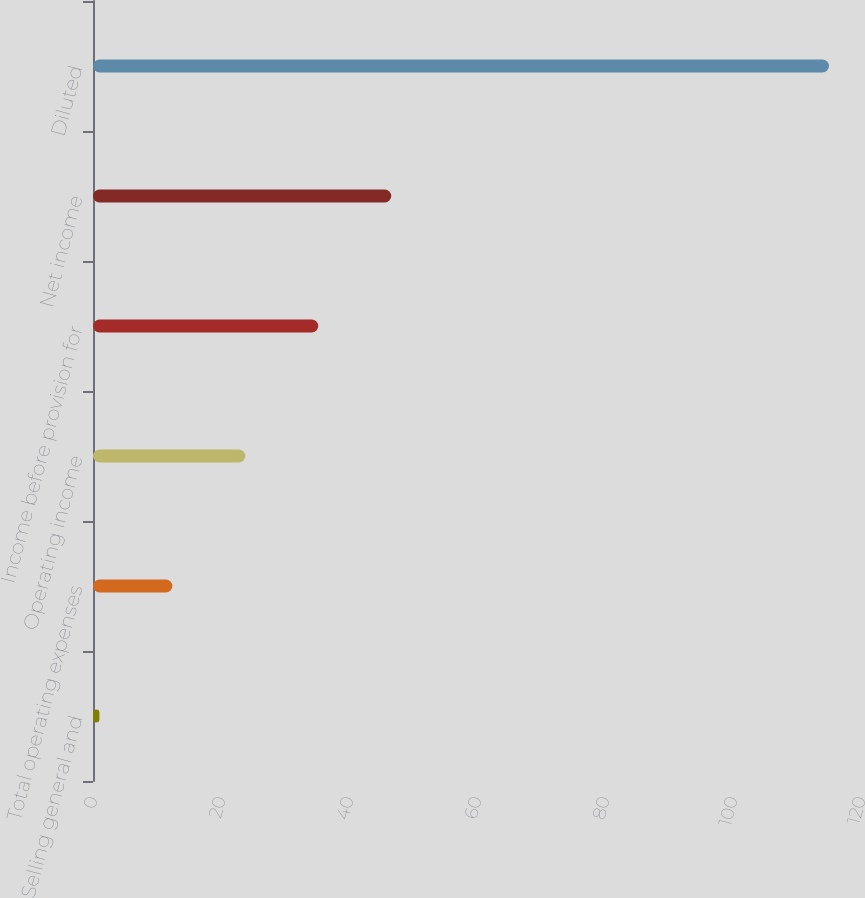Convert chart to OTSL. <chart><loc_0><loc_0><loc_500><loc_500><bar_chart><fcel>Selling general and<fcel>Total operating expenses<fcel>Operating income<fcel>Income before provision for<fcel>Net income<fcel>Diluted<nl><fcel>1<fcel>12.4<fcel>23.8<fcel>35.2<fcel>46.6<fcel>115<nl></chart> 